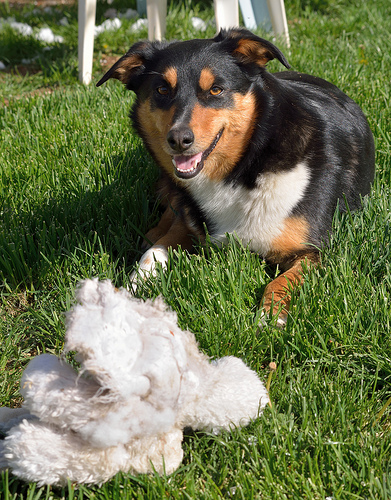<image>
Is the dog on the grass? Yes. Looking at the image, I can see the dog is positioned on top of the grass, with the grass providing support. Is there a grass under the dog? Yes. The grass is positioned underneath the dog, with the dog above it in the vertical space. Where is the dog in relation to the chair? Is it behind the chair? No. The dog is not behind the chair. From this viewpoint, the dog appears to be positioned elsewhere in the scene. 